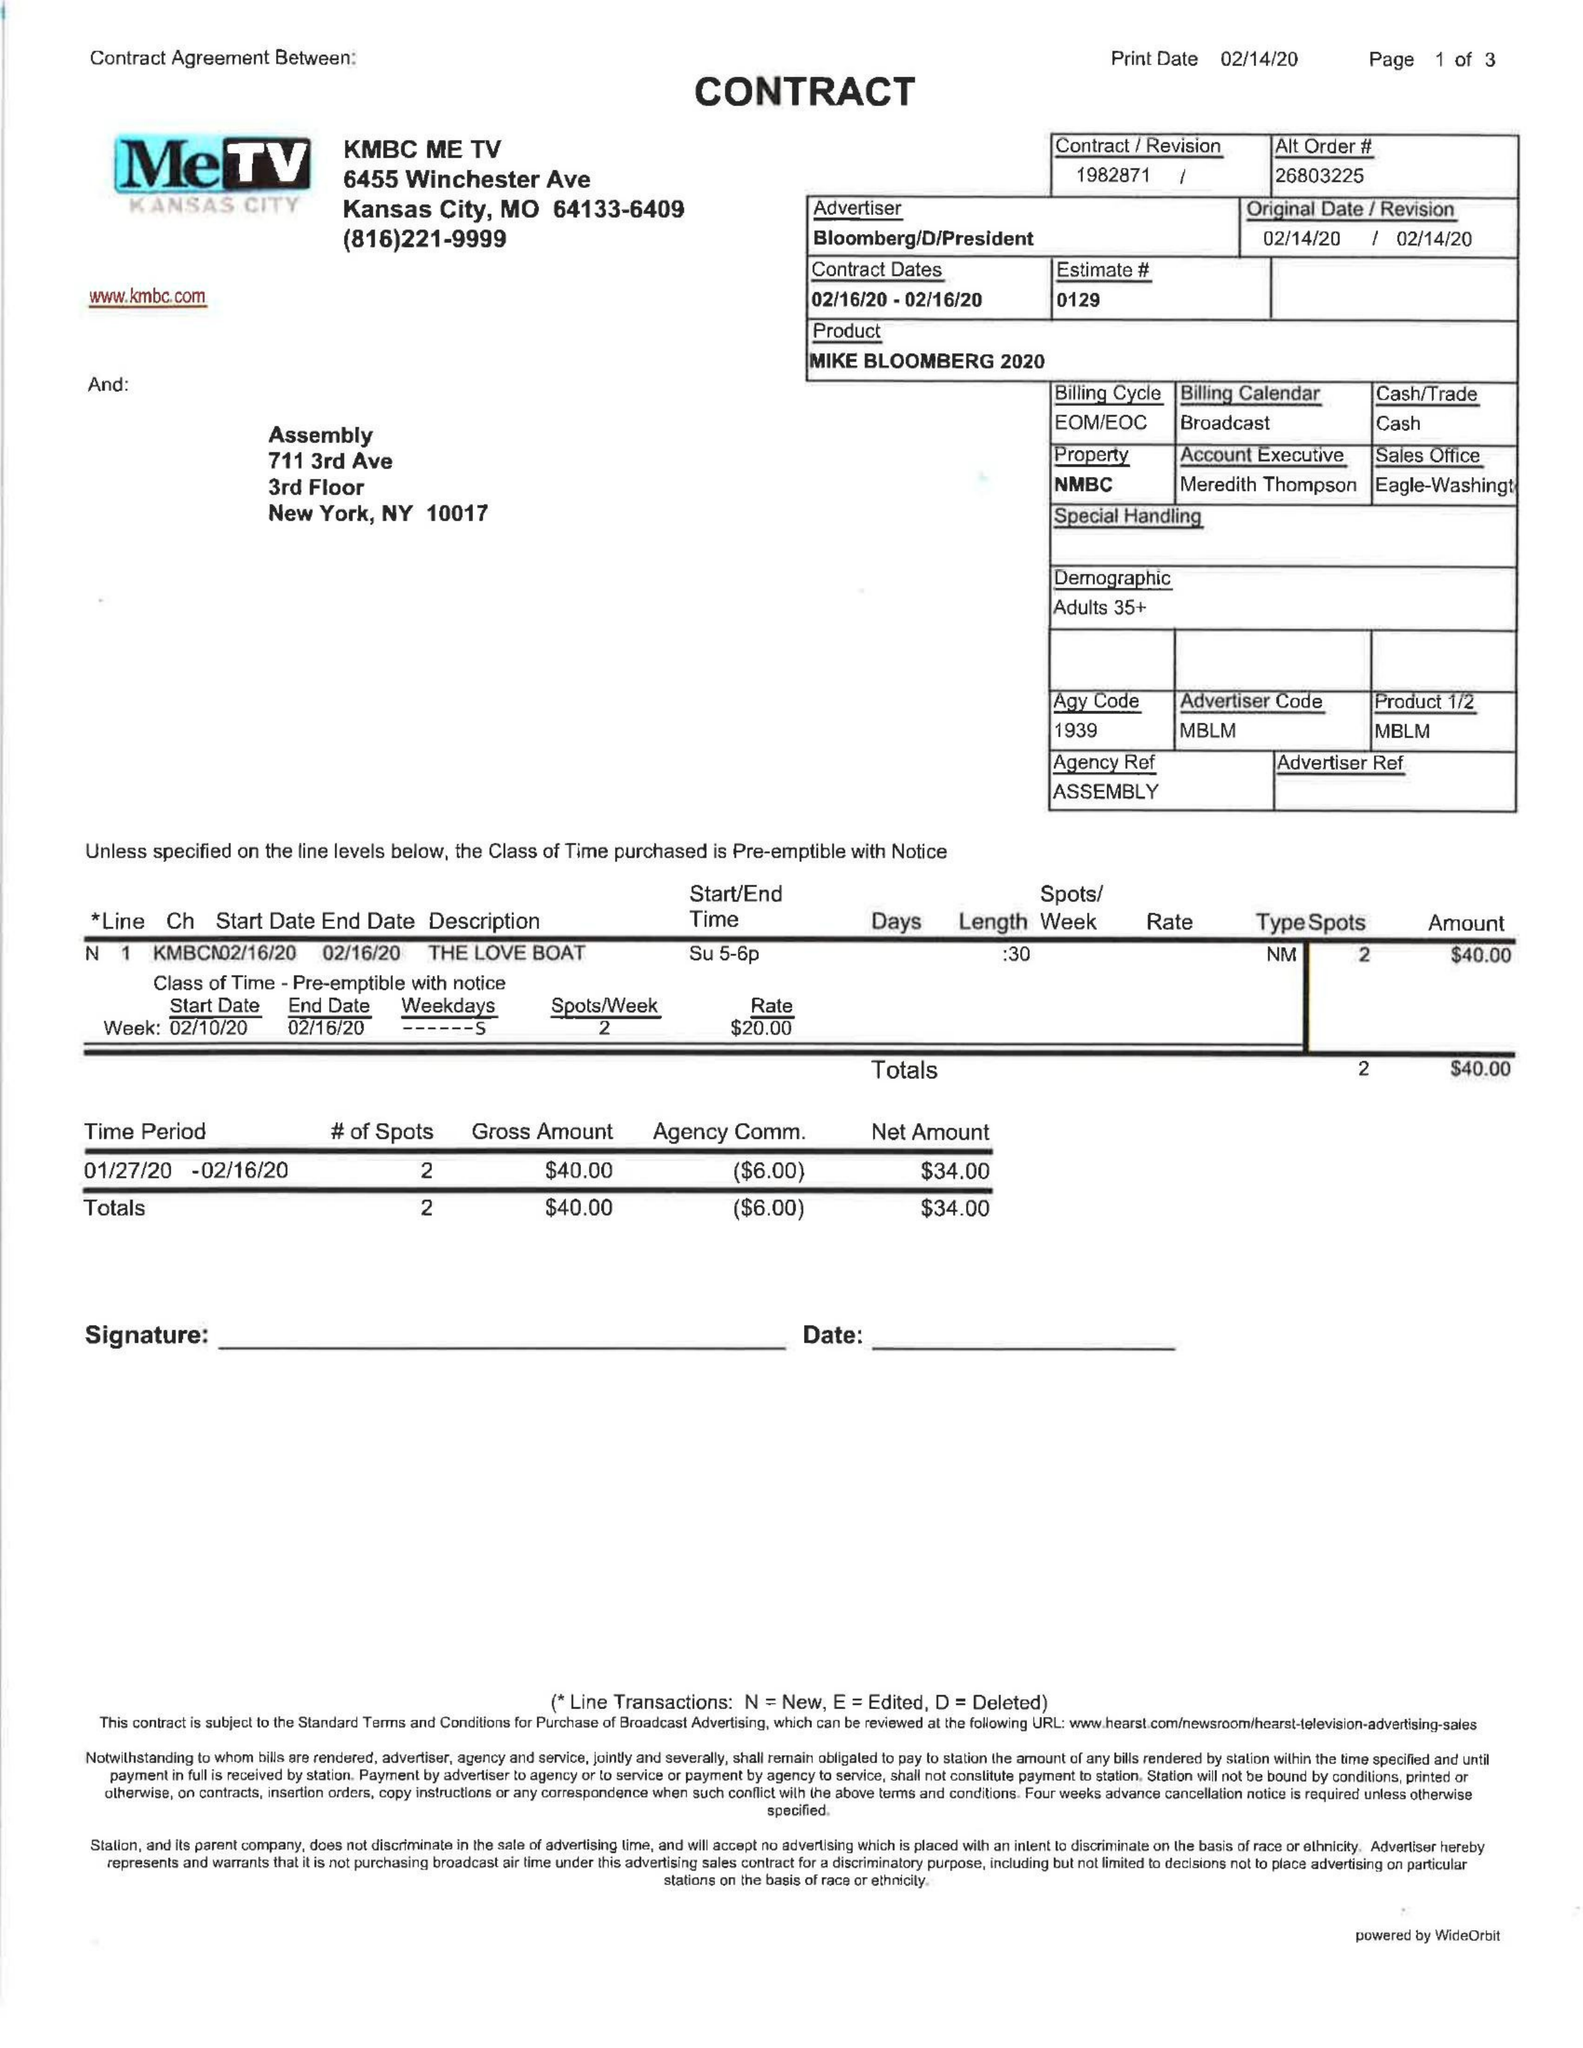What is the value for the flight_to?
Answer the question using a single word or phrase. 02/16/20 